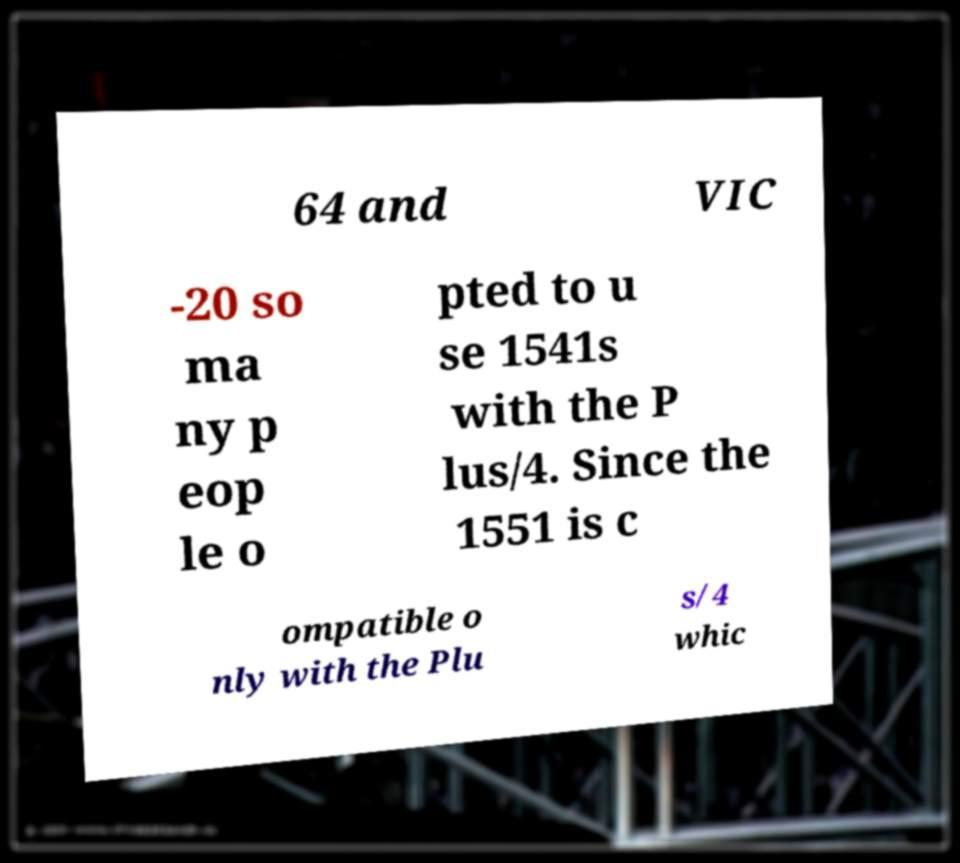Can you accurately transcribe the text from the provided image for me? 64 and VIC -20 so ma ny p eop le o pted to u se 1541s with the P lus/4. Since the 1551 is c ompatible o nly with the Plu s/4 whic 